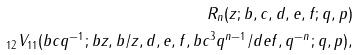<formula> <loc_0><loc_0><loc_500><loc_500>R _ { n } ( z ; b , c , d , e , f ; q , p ) \\ _ { 1 2 } V _ { 1 1 } ( b c q ^ { - 1 } ; b z , b / z , d , e , f , b c ^ { 3 } q ^ { n - 1 } / d e f , q ^ { - n } ; q , p ) ,</formula> 